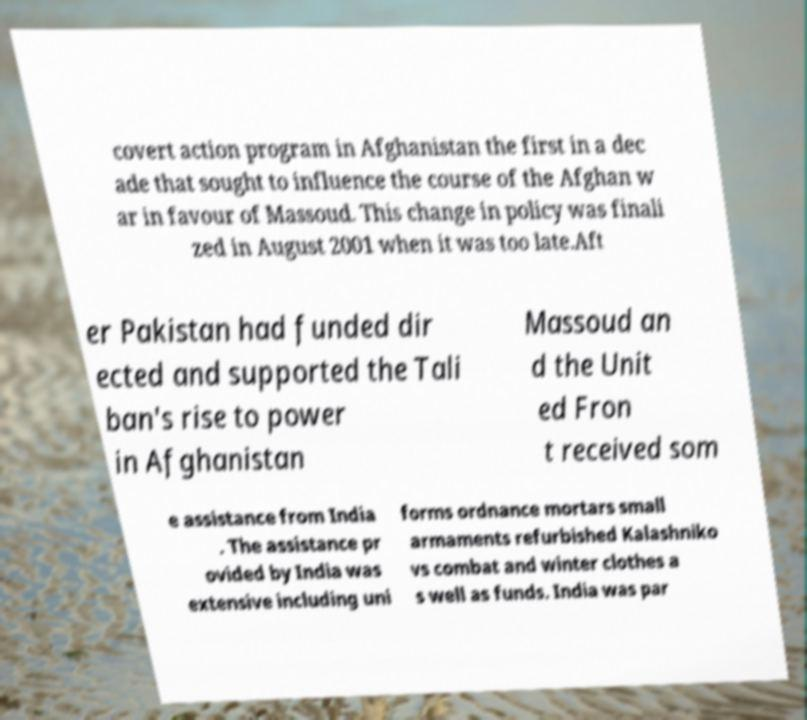For documentation purposes, I need the text within this image transcribed. Could you provide that? covert action program in Afghanistan the first in a dec ade that sought to influence the course of the Afghan w ar in favour of Massoud. This change in policy was finali zed in August 2001 when it was too late.Aft er Pakistan had funded dir ected and supported the Tali ban's rise to power in Afghanistan Massoud an d the Unit ed Fron t received som e assistance from India . The assistance pr ovided by India was extensive including uni forms ordnance mortars small armaments refurbished Kalashniko vs combat and winter clothes a s well as funds. India was par 